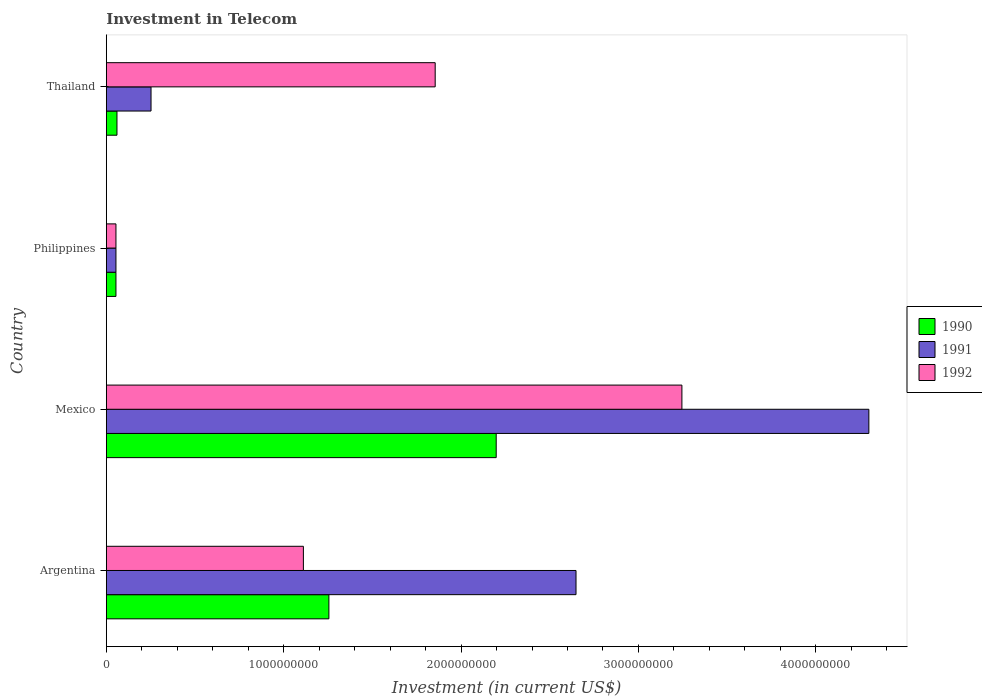Are the number of bars on each tick of the Y-axis equal?
Your response must be concise. Yes. What is the label of the 4th group of bars from the top?
Make the answer very short. Argentina. What is the amount invested in telecom in 1991 in Mexico?
Your answer should be compact. 4.30e+09. Across all countries, what is the maximum amount invested in telecom in 1990?
Give a very brief answer. 2.20e+09. Across all countries, what is the minimum amount invested in telecom in 1990?
Offer a very short reply. 5.42e+07. In which country was the amount invested in telecom in 1990 minimum?
Provide a short and direct response. Philippines. What is the total amount invested in telecom in 1991 in the graph?
Provide a short and direct response. 7.25e+09. What is the difference between the amount invested in telecom in 1991 in Philippines and that in Thailand?
Make the answer very short. -1.98e+08. What is the difference between the amount invested in telecom in 1990 in Argentina and the amount invested in telecom in 1992 in Thailand?
Your response must be concise. -5.99e+08. What is the average amount invested in telecom in 1991 per country?
Ensure brevity in your answer.  1.81e+09. What is the difference between the amount invested in telecom in 1991 and amount invested in telecom in 1990 in Thailand?
Provide a succinct answer. 1.92e+08. What is the ratio of the amount invested in telecom in 1990 in Philippines to that in Thailand?
Keep it short and to the point. 0.9. Is the amount invested in telecom in 1992 in Argentina less than that in Mexico?
Provide a succinct answer. Yes. What is the difference between the highest and the second highest amount invested in telecom in 1991?
Ensure brevity in your answer.  1.65e+09. What is the difference between the highest and the lowest amount invested in telecom in 1990?
Offer a very short reply. 2.14e+09. In how many countries, is the amount invested in telecom in 1990 greater than the average amount invested in telecom in 1990 taken over all countries?
Provide a short and direct response. 2. What does the 1st bar from the top in Mexico represents?
Provide a short and direct response. 1992. Is it the case that in every country, the sum of the amount invested in telecom in 1990 and amount invested in telecom in 1991 is greater than the amount invested in telecom in 1992?
Provide a succinct answer. No. How many bars are there?
Offer a very short reply. 12. What is the difference between two consecutive major ticks on the X-axis?
Your answer should be compact. 1.00e+09. Are the values on the major ticks of X-axis written in scientific E-notation?
Ensure brevity in your answer.  No. Does the graph contain grids?
Your answer should be compact. No. How are the legend labels stacked?
Provide a succinct answer. Vertical. What is the title of the graph?
Your answer should be compact. Investment in Telecom. Does "1980" appear as one of the legend labels in the graph?
Your answer should be very brief. No. What is the label or title of the X-axis?
Provide a short and direct response. Investment (in current US$). What is the Investment (in current US$) in 1990 in Argentina?
Your response must be concise. 1.25e+09. What is the Investment (in current US$) of 1991 in Argentina?
Your answer should be very brief. 2.65e+09. What is the Investment (in current US$) in 1992 in Argentina?
Your response must be concise. 1.11e+09. What is the Investment (in current US$) in 1990 in Mexico?
Make the answer very short. 2.20e+09. What is the Investment (in current US$) in 1991 in Mexico?
Offer a very short reply. 4.30e+09. What is the Investment (in current US$) of 1992 in Mexico?
Offer a very short reply. 3.24e+09. What is the Investment (in current US$) of 1990 in Philippines?
Keep it short and to the point. 5.42e+07. What is the Investment (in current US$) in 1991 in Philippines?
Give a very brief answer. 5.42e+07. What is the Investment (in current US$) of 1992 in Philippines?
Offer a terse response. 5.42e+07. What is the Investment (in current US$) of 1990 in Thailand?
Your answer should be very brief. 6.00e+07. What is the Investment (in current US$) in 1991 in Thailand?
Ensure brevity in your answer.  2.52e+08. What is the Investment (in current US$) in 1992 in Thailand?
Your answer should be compact. 1.85e+09. Across all countries, what is the maximum Investment (in current US$) of 1990?
Your answer should be compact. 2.20e+09. Across all countries, what is the maximum Investment (in current US$) in 1991?
Give a very brief answer. 4.30e+09. Across all countries, what is the maximum Investment (in current US$) in 1992?
Provide a short and direct response. 3.24e+09. Across all countries, what is the minimum Investment (in current US$) in 1990?
Offer a very short reply. 5.42e+07. Across all countries, what is the minimum Investment (in current US$) of 1991?
Ensure brevity in your answer.  5.42e+07. Across all countries, what is the minimum Investment (in current US$) of 1992?
Keep it short and to the point. 5.42e+07. What is the total Investment (in current US$) of 1990 in the graph?
Make the answer very short. 3.57e+09. What is the total Investment (in current US$) of 1991 in the graph?
Your response must be concise. 7.25e+09. What is the total Investment (in current US$) of 1992 in the graph?
Keep it short and to the point. 6.26e+09. What is the difference between the Investment (in current US$) in 1990 in Argentina and that in Mexico?
Your answer should be compact. -9.43e+08. What is the difference between the Investment (in current US$) of 1991 in Argentina and that in Mexico?
Give a very brief answer. -1.65e+09. What is the difference between the Investment (in current US$) of 1992 in Argentina and that in Mexico?
Keep it short and to the point. -2.13e+09. What is the difference between the Investment (in current US$) in 1990 in Argentina and that in Philippines?
Your answer should be very brief. 1.20e+09. What is the difference between the Investment (in current US$) in 1991 in Argentina and that in Philippines?
Your answer should be compact. 2.59e+09. What is the difference between the Investment (in current US$) of 1992 in Argentina and that in Philippines?
Your answer should be compact. 1.06e+09. What is the difference between the Investment (in current US$) in 1990 in Argentina and that in Thailand?
Offer a terse response. 1.19e+09. What is the difference between the Investment (in current US$) of 1991 in Argentina and that in Thailand?
Your answer should be compact. 2.40e+09. What is the difference between the Investment (in current US$) of 1992 in Argentina and that in Thailand?
Offer a terse response. -7.43e+08. What is the difference between the Investment (in current US$) of 1990 in Mexico and that in Philippines?
Make the answer very short. 2.14e+09. What is the difference between the Investment (in current US$) of 1991 in Mexico and that in Philippines?
Ensure brevity in your answer.  4.24e+09. What is the difference between the Investment (in current US$) in 1992 in Mexico and that in Philippines?
Offer a terse response. 3.19e+09. What is the difference between the Investment (in current US$) in 1990 in Mexico and that in Thailand?
Offer a terse response. 2.14e+09. What is the difference between the Investment (in current US$) of 1991 in Mexico and that in Thailand?
Your answer should be very brief. 4.05e+09. What is the difference between the Investment (in current US$) of 1992 in Mexico and that in Thailand?
Offer a terse response. 1.39e+09. What is the difference between the Investment (in current US$) in 1990 in Philippines and that in Thailand?
Give a very brief answer. -5.80e+06. What is the difference between the Investment (in current US$) of 1991 in Philippines and that in Thailand?
Provide a short and direct response. -1.98e+08. What is the difference between the Investment (in current US$) of 1992 in Philippines and that in Thailand?
Offer a very short reply. -1.80e+09. What is the difference between the Investment (in current US$) in 1990 in Argentina and the Investment (in current US$) in 1991 in Mexico?
Make the answer very short. -3.04e+09. What is the difference between the Investment (in current US$) of 1990 in Argentina and the Investment (in current US$) of 1992 in Mexico?
Offer a very short reply. -1.99e+09. What is the difference between the Investment (in current US$) of 1991 in Argentina and the Investment (in current US$) of 1992 in Mexico?
Provide a succinct answer. -5.97e+08. What is the difference between the Investment (in current US$) in 1990 in Argentina and the Investment (in current US$) in 1991 in Philippines?
Your response must be concise. 1.20e+09. What is the difference between the Investment (in current US$) of 1990 in Argentina and the Investment (in current US$) of 1992 in Philippines?
Offer a terse response. 1.20e+09. What is the difference between the Investment (in current US$) of 1991 in Argentina and the Investment (in current US$) of 1992 in Philippines?
Offer a very short reply. 2.59e+09. What is the difference between the Investment (in current US$) of 1990 in Argentina and the Investment (in current US$) of 1991 in Thailand?
Offer a very short reply. 1.00e+09. What is the difference between the Investment (in current US$) in 1990 in Argentina and the Investment (in current US$) in 1992 in Thailand?
Offer a very short reply. -5.99e+08. What is the difference between the Investment (in current US$) in 1991 in Argentina and the Investment (in current US$) in 1992 in Thailand?
Make the answer very short. 7.94e+08. What is the difference between the Investment (in current US$) in 1990 in Mexico and the Investment (in current US$) in 1991 in Philippines?
Your response must be concise. 2.14e+09. What is the difference between the Investment (in current US$) of 1990 in Mexico and the Investment (in current US$) of 1992 in Philippines?
Keep it short and to the point. 2.14e+09. What is the difference between the Investment (in current US$) of 1991 in Mexico and the Investment (in current US$) of 1992 in Philippines?
Your response must be concise. 4.24e+09. What is the difference between the Investment (in current US$) in 1990 in Mexico and the Investment (in current US$) in 1991 in Thailand?
Your answer should be compact. 1.95e+09. What is the difference between the Investment (in current US$) of 1990 in Mexico and the Investment (in current US$) of 1992 in Thailand?
Provide a short and direct response. 3.44e+08. What is the difference between the Investment (in current US$) of 1991 in Mexico and the Investment (in current US$) of 1992 in Thailand?
Make the answer very short. 2.44e+09. What is the difference between the Investment (in current US$) in 1990 in Philippines and the Investment (in current US$) in 1991 in Thailand?
Give a very brief answer. -1.98e+08. What is the difference between the Investment (in current US$) in 1990 in Philippines and the Investment (in current US$) in 1992 in Thailand?
Give a very brief answer. -1.80e+09. What is the difference between the Investment (in current US$) in 1991 in Philippines and the Investment (in current US$) in 1992 in Thailand?
Your answer should be very brief. -1.80e+09. What is the average Investment (in current US$) in 1990 per country?
Provide a short and direct response. 8.92e+08. What is the average Investment (in current US$) of 1991 per country?
Provide a succinct answer. 1.81e+09. What is the average Investment (in current US$) in 1992 per country?
Make the answer very short. 1.57e+09. What is the difference between the Investment (in current US$) of 1990 and Investment (in current US$) of 1991 in Argentina?
Offer a terse response. -1.39e+09. What is the difference between the Investment (in current US$) of 1990 and Investment (in current US$) of 1992 in Argentina?
Keep it short and to the point. 1.44e+08. What is the difference between the Investment (in current US$) in 1991 and Investment (in current US$) in 1992 in Argentina?
Your answer should be compact. 1.54e+09. What is the difference between the Investment (in current US$) in 1990 and Investment (in current US$) in 1991 in Mexico?
Your response must be concise. -2.10e+09. What is the difference between the Investment (in current US$) in 1990 and Investment (in current US$) in 1992 in Mexico?
Your answer should be compact. -1.05e+09. What is the difference between the Investment (in current US$) of 1991 and Investment (in current US$) of 1992 in Mexico?
Keep it short and to the point. 1.05e+09. What is the difference between the Investment (in current US$) of 1990 and Investment (in current US$) of 1991 in Philippines?
Keep it short and to the point. 0. What is the difference between the Investment (in current US$) of 1991 and Investment (in current US$) of 1992 in Philippines?
Give a very brief answer. 0. What is the difference between the Investment (in current US$) of 1990 and Investment (in current US$) of 1991 in Thailand?
Your response must be concise. -1.92e+08. What is the difference between the Investment (in current US$) in 1990 and Investment (in current US$) in 1992 in Thailand?
Your response must be concise. -1.79e+09. What is the difference between the Investment (in current US$) of 1991 and Investment (in current US$) of 1992 in Thailand?
Provide a short and direct response. -1.60e+09. What is the ratio of the Investment (in current US$) in 1990 in Argentina to that in Mexico?
Your answer should be very brief. 0.57. What is the ratio of the Investment (in current US$) of 1991 in Argentina to that in Mexico?
Your answer should be very brief. 0.62. What is the ratio of the Investment (in current US$) of 1992 in Argentina to that in Mexico?
Keep it short and to the point. 0.34. What is the ratio of the Investment (in current US$) of 1990 in Argentina to that in Philippines?
Ensure brevity in your answer.  23.15. What is the ratio of the Investment (in current US$) in 1991 in Argentina to that in Philippines?
Make the answer very short. 48.86. What is the ratio of the Investment (in current US$) of 1992 in Argentina to that in Philippines?
Keep it short and to the point. 20.5. What is the ratio of the Investment (in current US$) in 1990 in Argentina to that in Thailand?
Provide a succinct answer. 20.91. What is the ratio of the Investment (in current US$) of 1991 in Argentina to that in Thailand?
Keep it short and to the point. 10.51. What is the ratio of the Investment (in current US$) in 1992 in Argentina to that in Thailand?
Your response must be concise. 0.6. What is the ratio of the Investment (in current US$) in 1990 in Mexico to that in Philippines?
Offer a very short reply. 40.55. What is the ratio of the Investment (in current US$) of 1991 in Mexico to that in Philippines?
Ensure brevity in your answer.  79.32. What is the ratio of the Investment (in current US$) of 1992 in Mexico to that in Philippines?
Provide a succinct answer. 59.87. What is the ratio of the Investment (in current US$) of 1990 in Mexico to that in Thailand?
Offer a terse response. 36.63. What is the ratio of the Investment (in current US$) of 1991 in Mexico to that in Thailand?
Provide a succinct answer. 17.06. What is the ratio of the Investment (in current US$) in 1992 in Mexico to that in Thailand?
Ensure brevity in your answer.  1.75. What is the ratio of the Investment (in current US$) of 1990 in Philippines to that in Thailand?
Your answer should be compact. 0.9. What is the ratio of the Investment (in current US$) in 1991 in Philippines to that in Thailand?
Your answer should be compact. 0.22. What is the ratio of the Investment (in current US$) of 1992 in Philippines to that in Thailand?
Ensure brevity in your answer.  0.03. What is the difference between the highest and the second highest Investment (in current US$) in 1990?
Offer a terse response. 9.43e+08. What is the difference between the highest and the second highest Investment (in current US$) in 1991?
Offer a terse response. 1.65e+09. What is the difference between the highest and the second highest Investment (in current US$) in 1992?
Ensure brevity in your answer.  1.39e+09. What is the difference between the highest and the lowest Investment (in current US$) in 1990?
Make the answer very short. 2.14e+09. What is the difference between the highest and the lowest Investment (in current US$) of 1991?
Offer a terse response. 4.24e+09. What is the difference between the highest and the lowest Investment (in current US$) of 1992?
Make the answer very short. 3.19e+09. 